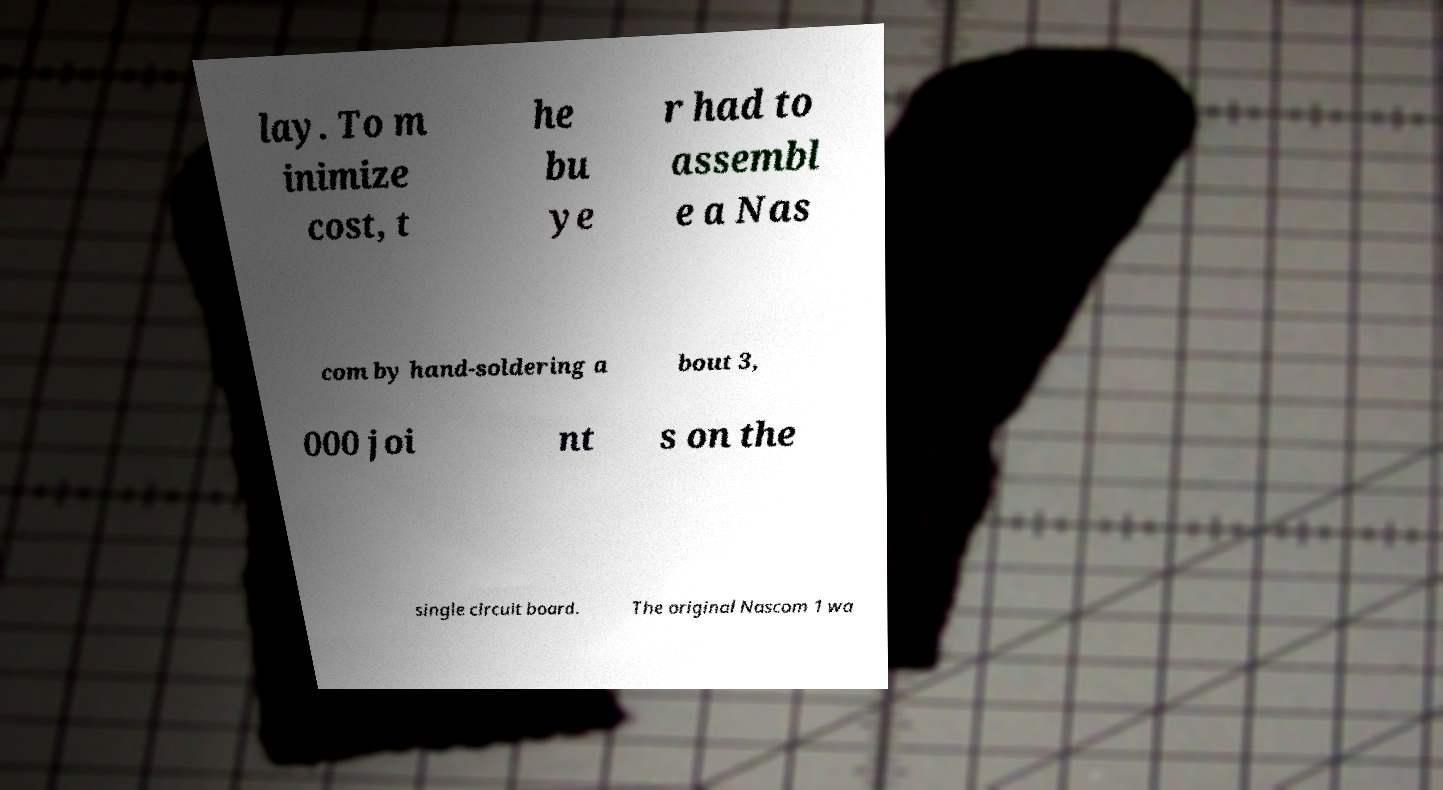Can you read and provide the text displayed in the image?This photo seems to have some interesting text. Can you extract and type it out for me? lay. To m inimize cost, t he bu ye r had to assembl e a Nas com by hand-soldering a bout 3, 000 joi nt s on the single circuit board. The original Nascom 1 wa 